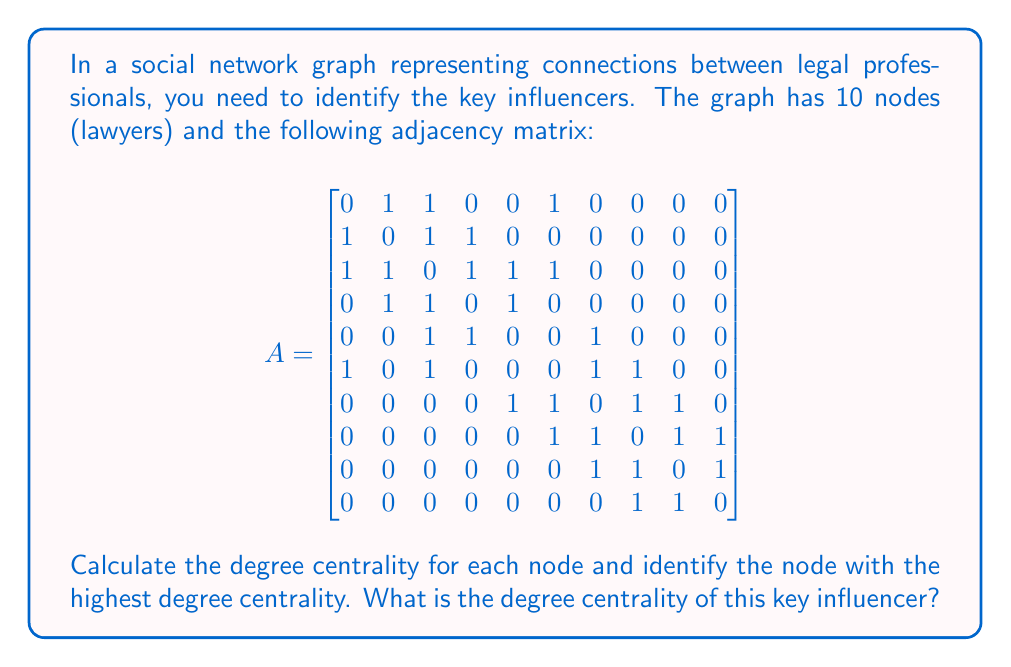Can you solve this math problem? To solve this problem, we'll follow these steps:

1) Degree centrality is defined as the number of connections a node has. In an undirected graph, it's the sum of the row (or column) in the adjacency matrix.

2) Let's calculate the degree for each node:

   Node 1: $1 + 1 + 1 = 3$
   Node 2: $1 + 1 + 1 = 3$
   Node 3: $1 + 1 + 1 + 1 + 1 = 5$
   Node 4: $1 + 1 + 1 = 3$
   Node 5: $1 + 1 + 1 = 3$
   Node 6: $1 + 1 + 1 + 1 = 4$
   Node 7: $1 + 1 + 1 + 1 = 4$
   Node 8: $1 + 1 + 1 + 1 = 4$
   Node 9: $1 + 1 + 1 = 3$
   Node 10: $1 + 1 = 2$

3) The node with the highest degree is Node 3 with a degree of 5.

4) To calculate the degree centrality, we normalize the degree by dividing it by the maximum possible degree (n-1, where n is the number of nodes).

   Degree centrality = $\frac{\text{degree}}{n-1} = \frac{5}{10-1} = \frac{5}{9} \approx 0.5556$

Therefore, the key influencer is Node 3 with a degree centrality of $\frac{5}{9}$.
Answer: $\frac{5}{9}$ 